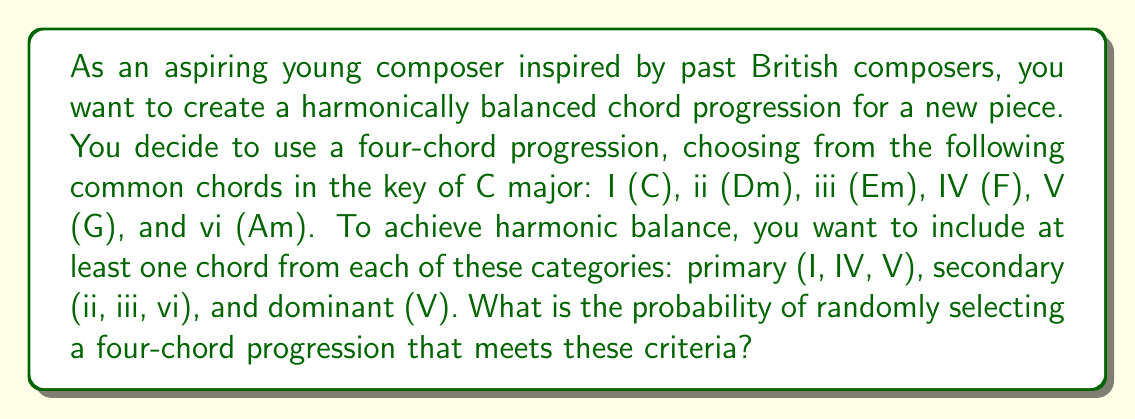Give your solution to this math problem. Let's approach this step-by-step:

1) First, we need to calculate the total number of possible four-chord progressions:
   $$\text{Total combinations} = 6^4 = 1296$$

2) Now, we need to find the number of combinations that meet our criteria. We can do this by considering the complement - the number of combinations that don't meet the criteria:

   a) Combinations without V (dominant):
      $$5^4 = 625$$

   b) Combinations without any secondary chords (ii, iii, vi):
      $$3^4 = 81$$

   c) Combinations without any primary chords except V:
      $$4^4 = 256$$

3) However, some combinations are counted multiple times in these subsets. We need to subtract these:

   d) Combinations with only I and IV:
      $$2^4 = 16$$

   e) Combinations with only secondary chords:
      $$3^4 = 81$$

4) Using the principle of inclusion-exclusion:

   $$\text{Valid combinations} = 1296 - (625 + 81 + 256 - 16 - 81) = 431$$

5) Therefore, the probability is:

   $$P(\text{balanced progression}) = \frac{431}{1296} \approx 0.3325$$
Answer: The probability of randomly selecting a four-chord progression that meets the criteria for harmonic balance is $\frac{431}{1296}$ or approximately 0.3325 (33.25%). 